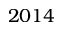<formula> <loc_0><loc_0><loc_500><loc_500>2 0 1 4</formula> 